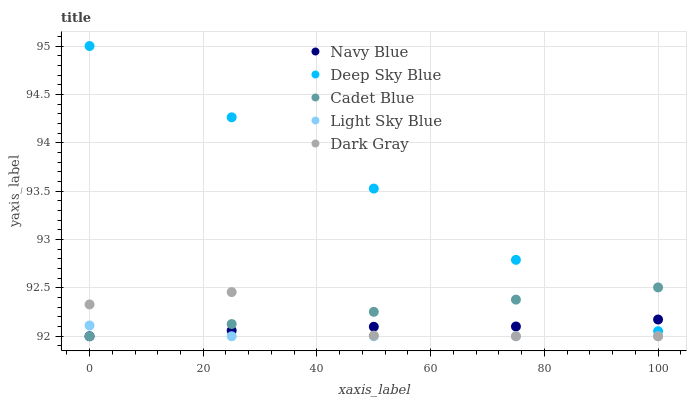Does Light Sky Blue have the minimum area under the curve?
Answer yes or no. Yes. Does Deep Sky Blue have the maximum area under the curve?
Answer yes or no. Yes. Does Navy Blue have the minimum area under the curve?
Answer yes or no. No. Does Navy Blue have the maximum area under the curve?
Answer yes or no. No. Is Cadet Blue the smoothest?
Answer yes or no. Yes. Is Dark Gray the roughest?
Answer yes or no. Yes. Is Navy Blue the smoothest?
Answer yes or no. No. Is Navy Blue the roughest?
Answer yes or no. No. Does Dark Gray have the lowest value?
Answer yes or no. Yes. Does Deep Sky Blue have the lowest value?
Answer yes or no. No. Does Deep Sky Blue have the highest value?
Answer yes or no. Yes. Does Navy Blue have the highest value?
Answer yes or no. No. Is Dark Gray less than Deep Sky Blue?
Answer yes or no. Yes. Is Deep Sky Blue greater than Dark Gray?
Answer yes or no. Yes. Does Deep Sky Blue intersect Cadet Blue?
Answer yes or no. Yes. Is Deep Sky Blue less than Cadet Blue?
Answer yes or no. No. Is Deep Sky Blue greater than Cadet Blue?
Answer yes or no. No. Does Dark Gray intersect Deep Sky Blue?
Answer yes or no. No. 